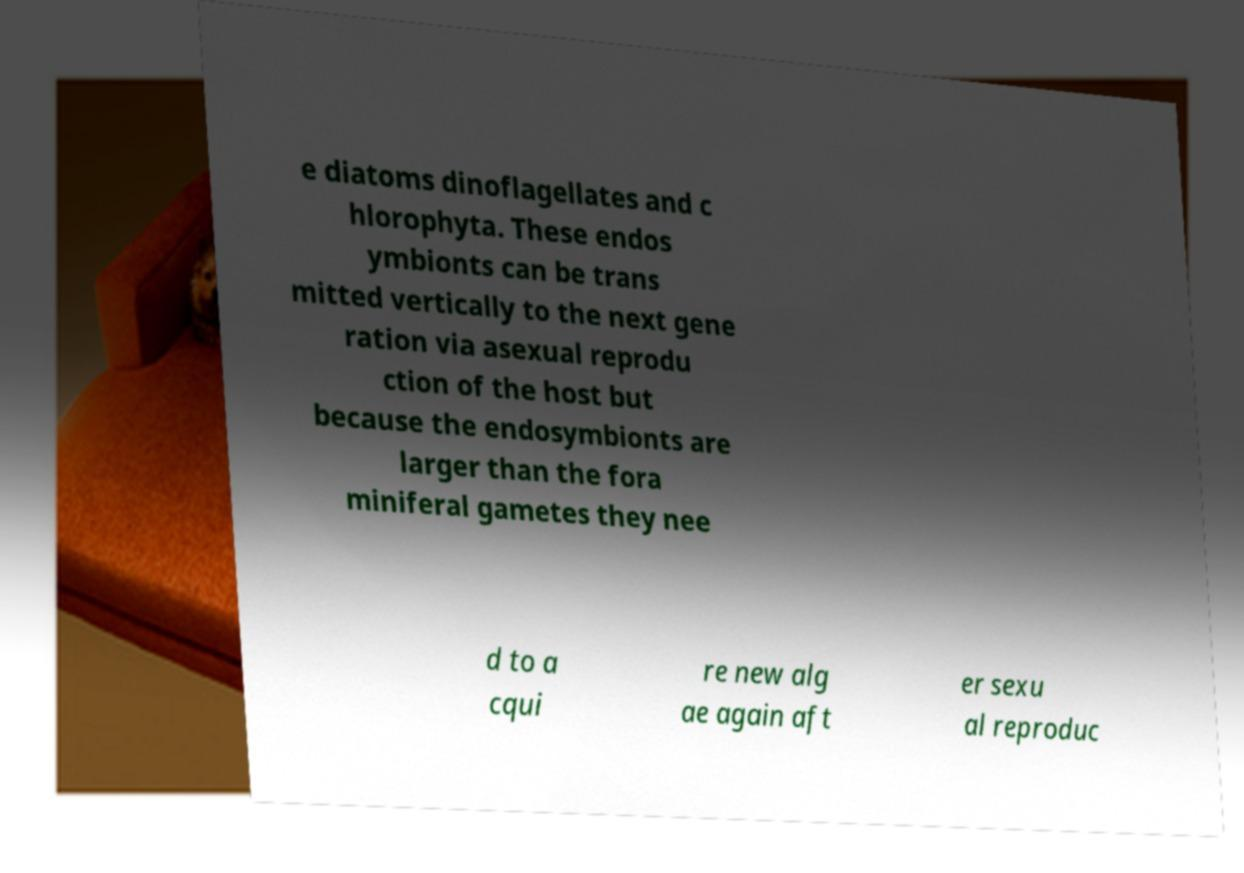Could you assist in decoding the text presented in this image and type it out clearly? e diatoms dinoflagellates and c hlorophyta. These endos ymbionts can be trans mitted vertically to the next gene ration via asexual reprodu ction of the host but because the endosymbionts are larger than the fora miniferal gametes they nee d to a cqui re new alg ae again aft er sexu al reproduc 